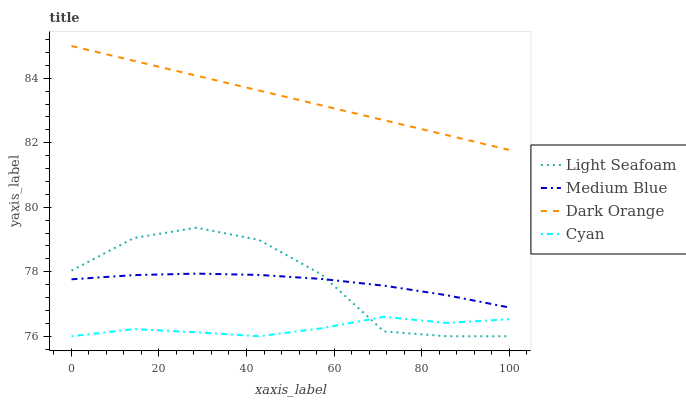Does Cyan have the minimum area under the curve?
Answer yes or no. Yes. Does Dark Orange have the maximum area under the curve?
Answer yes or no. Yes. Does Light Seafoam have the minimum area under the curve?
Answer yes or no. No. Does Light Seafoam have the maximum area under the curve?
Answer yes or no. No. Is Dark Orange the smoothest?
Answer yes or no. Yes. Is Light Seafoam the roughest?
Answer yes or no. Yes. Is Medium Blue the smoothest?
Answer yes or no. No. Is Medium Blue the roughest?
Answer yes or no. No. Does Light Seafoam have the lowest value?
Answer yes or no. Yes. Does Medium Blue have the lowest value?
Answer yes or no. No. Does Dark Orange have the highest value?
Answer yes or no. Yes. Does Light Seafoam have the highest value?
Answer yes or no. No. Is Cyan less than Medium Blue?
Answer yes or no. Yes. Is Medium Blue greater than Cyan?
Answer yes or no. Yes. Does Medium Blue intersect Light Seafoam?
Answer yes or no. Yes. Is Medium Blue less than Light Seafoam?
Answer yes or no. No. Is Medium Blue greater than Light Seafoam?
Answer yes or no. No. Does Cyan intersect Medium Blue?
Answer yes or no. No. 